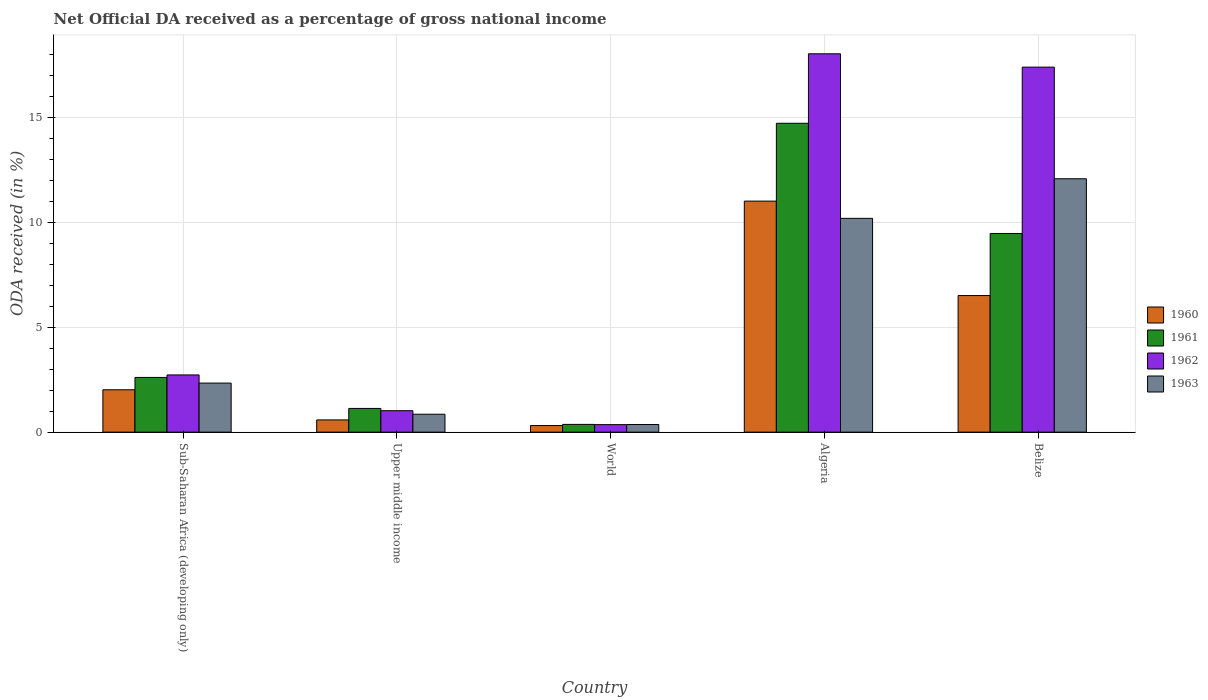Are the number of bars per tick equal to the number of legend labels?
Ensure brevity in your answer.  Yes. Are the number of bars on each tick of the X-axis equal?
Your answer should be compact. Yes. How many bars are there on the 3rd tick from the right?
Your response must be concise. 4. What is the label of the 3rd group of bars from the left?
Offer a terse response. World. In how many cases, is the number of bars for a given country not equal to the number of legend labels?
Provide a succinct answer. 0. What is the net official DA received in 1961 in Belize?
Your answer should be very brief. 9.48. Across all countries, what is the maximum net official DA received in 1963?
Make the answer very short. 12.09. Across all countries, what is the minimum net official DA received in 1961?
Offer a terse response. 0.37. In which country was the net official DA received in 1962 maximum?
Your answer should be very brief. Algeria. In which country was the net official DA received in 1963 minimum?
Offer a very short reply. World. What is the total net official DA received in 1963 in the graph?
Provide a short and direct response. 25.85. What is the difference between the net official DA received in 1963 in Algeria and that in Upper middle income?
Offer a very short reply. 9.34. What is the difference between the net official DA received in 1961 in Upper middle income and the net official DA received in 1960 in Sub-Saharan Africa (developing only)?
Your response must be concise. -0.89. What is the average net official DA received in 1960 per country?
Offer a very short reply. 4.09. What is the difference between the net official DA received of/in 1960 and net official DA received of/in 1963 in Belize?
Your response must be concise. -5.57. What is the ratio of the net official DA received in 1961 in Belize to that in World?
Offer a very short reply. 25.65. Is the net official DA received in 1961 in Algeria less than that in World?
Provide a succinct answer. No. What is the difference between the highest and the second highest net official DA received in 1961?
Provide a succinct answer. 6.87. What is the difference between the highest and the lowest net official DA received in 1963?
Offer a very short reply. 11.72. Is it the case that in every country, the sum of the net official DA received in 1961 and net official DA received in 1962 is greater than the sum of net official DA received in 1960 and net official DA received in 1963?
Make the answer very short. No. What does the 4th bar from the right in Sub-Saharan Africa (developing only) represents?
Give a very brief answer. 1960. What is the difference between two consecutive major ticks on the Y-axis?
Your answer should be compact. 5. Are the values on the major ticks of Y-axis written in scientific E-notation?
Ensure brevity in your answer.  No. Does the graph contain any zero values?
Provide a succinct answer. No. Does the graph contain grids?
Provide a succinct answer. Yes. Where does the legend appear in the graph?
Offer a very short reply. Center right. How many legend labels are there?
Give a very brief answer. 4. How are the legend labels stacked?
Give a very brief answer. Vertical. What is the title of the graph?
Your answer should be compact. Net Official DA received as a percentage of gross national income. What is the label or title of the Y-axis?
Give a very brief answer. ODA received (in %). What is the ODA received (in %) in 1960 in Sub-Saharan Africa (developing only)?
Ensure brevity in your answer.  2.02. What is the ODA received (in %) in 1961 in Sub-Saharan Africa (developing only)?
Offer a very short reply. 2.61. What is the ODA received (in %) of 1962 in Sub-Saharan Africa (developing only)?
Offer a very short reply. 2.73. What is the ODA received (in %) in 1963 in Sub-Saharan Africa (developing only)?
Your answer should be very brief. 2.34. What is the ODA received (in %) of 1960 in Upper middle income?
Make the answer very short. 0.58. What is the ODA received (in %) of 1961 in Upper middle income?
Ensure brevity in your answer.  1.13. What is the ODA received (in %) of 1962 in Upper middle income?
Provide a succinct answer. 1.02. What is the ODA received (in %) of 1963 in Upper middle income?
Your response must be concise. 0.86. What is the ODA received (in %) in 1960 in World?
Your response must be concise. 0.31. What is the ODA received (in %) of 1961 in World?
Make the answer very short. 0.37. What is the ODA received (in %) of 1962 in World?
Provide a short and direct response. 0.36. What is the ODA received (in %) of 1963 in World?
Your answer should be compact. 0.36. What is the ODA received (in %) of 1960 in Algeria?
Keep it short and to the point. 11.02. What is the ODA received (in %) in 1961 in Algeria?
Your answer should be compact. 14.73. What is the ODA received (in %) of 1962 in Algeria?
Offer a very short reply. 18.05. What is the ODA received (in %) in 1963 in Algeria?
Make the answer very short. 10.2. What is the ODA received (in %) in 1960 in Belize?
Your response must be concise. 6.52. What is the ODA received (in %) of 1961 in Belize?
Make the answer very short. 9.48. What is the ODA received (in %) of 1962 in Belize?
Give a very brief answer. 17.41. What is the ODA received (in %) in 1963 in Belize?
Keep it short and to the point. 12.09. Across all countries, what is the maximum ODA received (in %) of 1960?
Ensure brevity in your answer.  11.02. Across all countries, what is the maximum ODA received (in %) in 1961?
Provide a succinct answer. 14.73. Across all countries, what is the maximum ODA received (in %) in 1962?
Offer a terse response. 18.05. Across all countries, what is the maximum ODA received (in %) in 1963?
Provide a succinct answer. 12.09. Across all countries, what is the minimum ODA received (in %) of 1960?
Provide a short and direct response. 0.31. Across all countries, what is the minimum ODA received (in %) of 1961?
Make the answer very short. 0.37. Across all countries, what is the minimum ODA received (in %) of 1962?
Provide a short and direct response. 0.36. Across all countries, what is the minimum ODA received (in %) in 1963?
Ensure brevity in your answer.  0.36. What is the total ODA received (in %) in 1960 in the graph?
Your answer should be compact. 20.46. What is the total ODA received (in %) of 1961 in the graph?
Provide a succinct answer. 28.32. What is the total ODA received (in %) of 1962 in the graph?
Ensure brevity in your answer.  39.57. What is the total ODA received (in %) of 1963 in the graph?
Your answer should be compact. 25.85. What is the difference between the ODA received (in %) of 1960 in Sub-Saharan Africa (developing only) and that in Upper middle income?
Your answer should be compact. 1.44. What is the difference between the ODA received (in %) in 1961 in Sub-Saharan Africa (developing only) and that in Upper middle income?
Your response must be concise. 1.48. What is the difference between the ODA received (in %) of 1962 in Sub-Saharan Africa (developing only) and that in Upper middle income?
Give a very brief answer. 1.71. What is the difference between the ODA received (in %) in 1963 in Sub-Saharan Africa (developing only) and that in Upper middle income?
Offer a very short reply. 1.49. What is the difference between the ODA received (in %) in 1960 in Sub-Saharan Africa (developing only) and that in World?
Offer a terse response. 1.71. What is the difference between the ODA received (in %) in 1961 in Sub-Saharan Africa (developing only) and that in World?
Your answer should be very brief. 2.24. What is the difference between the ODA received (in %) of 1962 in Sub-Saharan Africa (developing only) and that in World?
Your answer should be compact. 2.37. What is the difference between the ODA received (in %) in 1963 in Sub-Saharan Africa (developing only) and that in World?
Ensure brevity in your answer.  1.98. What is the difference between the ODA received (in %) in 1960 in Sub-Saharan Africa (developing only) and that in Algeria?
Your answer should be very brief. -9. What is the difference between the ODA received (in %) in 1961 in Sub-Saharan Africa (developing only) and that in Algeria?
Ensure brevity in your answer.  -12.12. What is the difference between the ODA received (in %) in 1962 in Sub-Saharan Africa (developing only) and that in Algeria?
Provide a short and direct response. -15.32. What is the difference between the ODA received (in %) in 1963 in Sub-Saharan Africa (developing only) and that in Algeria?
Your answer should be very brief. -7.86. What is the difference between the ODA received (in %) in 1960 in Sub-Saharan Africa (developing only) and that in Belize?
Offer a very short reply. -4.49. What is the difference between the ODA received (in %) in 1961 in Sub-Saharan Africa (developing only) and that in Belize?
Provide a short and direct response. -6.87. What is the difference between the ODA received (in %) in 1962 in Sub-Saharan Africa (developing only) and that in Belize?
Offer a terse response. -14.68. What is the difference between the ODA received (in %) of 1963 in Sub-Saharan Africa (developing only) and that in Belize?
Your answer should be very brief. -9.75. What is the difference between the ODA received (in %) in 1960 in Upper middle income and that in World?
Offer a very short reply. 0.27. What is the difference between the ODA received (in %) in 1961 in Upper middle income and that in World?
Keep it short and to the point. 0.76. What is the difference between the ODA received (in %) in 1962 in Upper middle income and that in World?
Ensure brevity in your answer.  0.66. What is the difference between the ODA received (in %) in 1963 in Upper middle income and that in World?
Your answer should be compact. 0.49. What is the difference between the ODA received (in %) of 1960 in Upper middle income and that in Algeria?
Provide a succinct answer. -10.44. What is the difference between the ODA received (in %) of 1961 in Upper middle income and that in Algeria?
Your response must be concise. -13.6. What is the difference between the ODA received (in %) in 1962 in Upper middle income and that in Algeria?
Give a very brief answer. -17.03. What is the difference between the ODA received (in %) of 1963 in Upper middle income and that in Algeria?
Ensure brevity in your answer.  -9.34. What is the difference between the ODA received (in %) in 1960 in Upper middle income and that in Belize?
Provide a succinct answer. -5.93. What is the difference between the ODA received (in %) of 1961 in Upper middle income and that in Belize?
Your response must be concise. -8.35. What is the difference between the ODA received (in %) of 1962 in Upper middle income and that in Belize?
Your answer should be very brief. -16.39. What is the difference between the ODA received (in %) of 1963 in Upper middle income and that in Belize?
Offer a very short reply. -11.23. What is the difference between the ODA received (in %) of 1960 in World and that in Algeria?
Provide a succinct answer. -10.71. What is the difference between the ODA received (in %) of 1961 in World and that in Algeria?
Your answer should be compact. -14.36. What is the difference between the ODA received (in %) in 1962 in World and that in Algeria?
Give a very brief answer. -17.69. What is the difference between the ODA received (in %) in 1963 in World and that in Algeria?
Provide a short and direct response. -9.83. What is the difference between the ODA received (in %) in 1960 in World and that in Belize?
Make the answer very short. -6.2. What is the difference between the ODA received (in %) of 1961 in World and that in Belize?
Ensure brevity in your answer.  -9.11. What is the difference between the ODA received (in %) of 1962 in World and that in Belize?
Provide a short and direct response. -17.05. What is the difference between the ODA received (in %) in 1963 in World and that in Belize?
Your answer should be compact. -11.72. What is the difference between the ODA received (in %) of 1960 in Algeria and that in Belize?
Make the answer very short. 4.51. What is the difference between the ODA received (in %) in 1961 in Algeria and that in Belize?
Offer a very short reply. 5.26. What is the difference between the ODA received (in %) of 1962 in Algeria and that in Belize?
Your answer should be very brief. 0.64. What is the difference between the ODA received (in %) of 1963 in Algeria and that in Belize?
Ensure brevity in your answer.  -1.89. What is the difference between the ODA received (in %) in 1960 in Sub-Saharan Africa (developing only) and the ODA received (in %) in 1961 in Upper middle income?
Provide a succinct answer. 0.89. What is the difference between the ODA received (in %) of 1960 in Sub-Saharan Africa (developing only) and the ODA received (in %) of 1962 in Upper middle income?
Your answer should be very brief. 1. What is the difference between the ODA received (in %) in 1960 in Sub-Saharan Africa (developing only) and the ODA received (in %) in 1963 in Upper middle income?
Offer a terse response. 1.17. What is the difference between the ODA received (in %) in 1961 in Sub-Saharan Africa (developing only) and the ODA received (in %) in 1962 in Upper middle income?
Offer a terse response. 1.59. What is the difference between the ODA received (in %) of 1961 in Sub-Saharan Africa (developing only) and the ODA received (in %) of 1963 in Upper middle income?
Make the answer very short. 1.75. What is the difference between the ODA received (in %) of 1962 in Sub-Saharan Africa (developing only) and the ODA received (in %) of 1963 in Upper middle income?
Offer a terse response. 1.87. What is the difference between the ODA received (in %) of 1960 in Sub-Saharan Africa (developing only) and the ODA received (in %) of 1961 in World?
Keep it short and to the point. 1.65. What is the difference between the ODA received (in %) in 1960 in Sub-Saharan Africa (developing only) and the ODA received (in %) in 1962 in World?
Offer a very short reply. 1.66. What is the difference between the ODA received (in %) of 1960 in Sub-Saharan Africa (developing only) and the ODA received (in %) of 1963 in World?
Give a very brief answer. 1.66. What is the difference between the ODA received (in %) in 1961 in Sub-Saharan Africa (developing only) and the ODA received (in %) in 1962 in World?
Make the answer very short. 2.25. What is the difference between the ODA received (in %) in 1961 in Sub-Saharan Africa (developing only) and the ODA received (in %) in 1963 in World?
Your answer should be very brief. 2.25. What is the difference between the ODA received (in %) in 1962 in Sub-Saharan Africa (developing only) and the ODA received (in %) in 1963 in World?
Make the answer very short. 2.36. What is the difference between the ODA received (in %) of 1960 in Sub-Saharan Africa (developing only) and the ODA received (in %) of 1961 in Algeria?
Provide a succinct answer. -12.71. What is the difference between the ODA received (in %) of 1960 in Sub-Saharan Africa (developing only) and the ODA received (in %) of 1962 in Algeria?
Keep it short and to the point. -16.03. What is the difference between the ODA received (in %) of 1960 in Sub-Saharan Africa (developing only) and the ODA received (in %) of 1963 in Algeria?
Your response must be concise. -8.18. What is the difference between the ODA received (in %) of 1961 in Sub-Saharan Africa (developing only) and the ODA received (in %) of 1962 in Algeria?
Keep it short and to the point. -15.44. What is the difference between the ODA received (in %) in 1961 in Sub-Saharan Africa (developing only) and the ODA received (in %) in 1963 in Algeria?
Offer a terse response. -7.59. What is the difference between the ODA received (in %) of 1962 in Sub-Saharan Africa (developing only) and the ODA received (in %) of 1963 in Algeria?
Your answer should be compact. -7.47. What is the difference between the ODA received (in %) of 1960 in Sub-Saharan Africa (developing only) and the ODA received (in %) of 1961 in Belize?
Make the answer very short. -7.46. What is the difference between the ODA received (in %) of 1960 in Sub-Saharan Africa (developing only) and the ODA received (in %) of 1962 in Belize?
Keep it short and to the point. -15.39. What is the difference between the ODA received (in %) of 1960 in Sub-Saharan Africa (developing only) and the ODA received (in %) of 1963 in Belize?
Provide a succinct answer. -10.07. What is the difference between the ODA received (in %) of 1961 in Sub-Saharan Africa (developing only) and the ODA received (in %) of 1962 in Belize?
Make the answer very short. -14.8. What is the difference between the ODA received (in %) in 1961 in Sub-Saharan Africa (developing only) and the ODA received (in %) in 1963 in Belize?
Ensure brevity in your answer.  -9.48. What is the difference between the ODA received (in %) of 1962 in Sub-Saharan Africa (developing only) and the ODA received (in %) of 1963 in Belize?
Your answer should be compact. -9.36. What is the difference between the ODA received (in %) of 1960 in Upper middle income and the ODA received (in %) of 1961 in World?
Keep it short and to the point. 0.21. What is the difference between the ODA received (in %) in 1960 in Upper middle income and the ODA received (in %) in 1962 in World?
Give a very brief answer. 0.23. What is the difference between the ODA received (in %) in 1960 in Upper middle income and the ODA received (in %) in 1963 in World?
Your response must be concise. 0.22. What is the difference between the ODA received (in %) of 1961 in Upper middle income and the ODA received (in %) of 1962 in World?
Offer a very short reply. 0.77. What is the difference between the ODA received (in %) of 1961 in Upper middle income and the ODA received (in %) of 1963 in World?
Ensure brevity in your answer.  0.77. What is the difference between the ODA received (in %) of 1962 in Upper middle income and the ODA received (in %) of 1963 in World?
Your response must be concise. 0.66. What is the difference between the ODA received (in %) in 1960 in Upper middle income and the ODA received (in %) in 1961 in Algeria?
Offer a very short reply. -14.15. What is the difference between the ODA received (in %) of 1960 in Upper middle income and the ODA received (in %) of 1962 in Algeria?
Provide a short and direct response. -17.46. What is the difference between the ODA received (in %) of 1960 in Upper middle income and the ODA received (in %) of 1963 in Algeria?
Your response must be concise. -9.61. What is the difference between the ODA received (in %) of 1961 in Upper middle income and the ODA received (in %) of 1962 in Algeria?
Make the answer very short. -16.92. What is the difference between the ODA received (in %) of 1961 in Upper middle income and the ODA received (in %) of 1963 in Algeria?
Provide a short and direct response. -9.07. What is the difference between the ODA received (in %) of 1962 in Upper middle income and the ODA received (in %) of 1963 in Algeria?
Give a very brief answer. -9.18. What is the difference between the ODA received (in %) in 1960 in Upper middle income and the ODA received (in %) in 1961 in Belize?
Your answer should be compact. -8.89. What is the difference between the ODA received (in %) in 1960 in Upper middle income and the ODA received (in %) in 1962 in Belize?
Ensure brevity in your answer.  -16.83. What is the difference between the ODA received (in %) in 1960 in Upper middle income and the ODA received (in %) in 1963 in Belize?
Offer a very short reply. -11.5. What is the difference between the ODA received (in %) in 1961 in Upper middle income and the ODA received (in %) in 1962 in Belize?
Your response must be concise. -16.28. What is the difference between the ODA received (in %) of 1961 in Upper middle income and the ODA received (in %) of 1963 in Belize?
Keep it short and to the point. -10.96. What is the difference between the ODA received (in %) in 1962 in Upper middle income and the ODA received (in %) in 1963 in Belize?
Give a very brief answer. -11.07. What is the difference between the ODA received (in %) in 1960 in World and the ODA received (in %) in 1961 in Algeria?
Provide a short and direct response. -14.42. What is the difference between the ODA received (in %) of 1960 in World and the ODA received (in %) of 1962 in Algeria?
Offer a very short reply. -17.73. What is the difference between the ODA received (in %) of 1960 in World and the ODA received (in %) of 1963 in Algeria?
Your response must be concise. -9.88. What is the difference between the ODA received (in %) in 1961 in World and the ODA received (in %) in 1962 in Algeria?
Give a very brief answer. -17.68. What is the difference between the ODA received (in %) of 1961 in World and the ODA received (in %) of 1963 in Algeria?
Your answer should be compact. -9.83. What is the difference between the ODA received (in %) in 1962 in World and the ODA received (in %) in 1963 in Algeria?
Your response must be concise. -9.84. What is the difference between the ODA received (in %) in 1960 in World and the ODA received (in %) in 1961 in Belize?
Give a very brief answer. -9.16. What is the difference between the ODA received (in %) of 1960 in World and the ODA received (in %) of 1962 in Belize?
Ensure brevity in your answer.  -17.1. What is the difference between the ODA received (in %) in 1960 in World and the ODA received (in %) in 1963 in Belize?
Keep it short and to the point. -11.77. What is the difference between the ODA received (in %) of 1961 in World and the ODA received (in %) of 1962 in Belize?
Offer a terse response. -17.04. What is the difference between the ODA received (in %) in 1961 in World and the ODA received (in %) in 1963 in Belize?
Provide a succinct answer. -11.72. What is the difference between the ODA received (in %) of 1962 in World and the ODA received (in %) of 1963 in Belize?
Your answer should be very brief. -11.73. What is the difference between the ODA received (in %) of 1960 in Algeria and the ODA received (in %) of 1961 in Belize?
Provide a short and direct response. 1.54. What is the difference between the ODA received (in %) of 1960 in Algeria and the ODA received (in %) of 1962 in Belize?
Ensure brevity in your answer.  -6.39. What is the difference between the ODA received (in %) in 1960 in Algeria and the ODA received (in %) in 1963 in Belize?
Offer a very short reply. -1.07. What is the difference between the ODA received (in %) in 1961 in Algeria and the ODA received (in %) in 1962 in Belize?
Give a very brief answer. -2.68. What is the difference between the ODA received (in %) in 1961 in Algeria and the ODA received (in %) in 1963 in Belize?
Your answer should be compact. 2.65. What is the difference between the ODA received (in %) of 1962 in Algeria and the ODA received (in %) of 1963 in Belize?
Offer a terse response. 5.96. What is the average ODA received (in %) of 1960 per country?
Your answer should be compact. 4.09. What is the average ODA received (in %) in 1961 per country?
Your response must be concise. 5.66. What is the average ODA received (in %) of 1962 per country?
Offer a very short reply. 7.91. What is the average ODA received (in %) of 1963 per country?
Make the answer very short. 5.17. What is the difference between the ODA received (in %) in 1960 and ODA received (in %) in 1961 in Sub-Saharan Africa (developing only)?
Ensure brevity in your answer.  -0.59. What is the difference between the ODA received (in %) of 1960 and ODA received (in %) of 1962 in Sub-Saharan Africa (developing only)?
Give a very brief answer. -0.71. What is the difference between the ODA received (in %) in 1960 and ODA received (in %) in 1963 in Sub-Saharan Africa (developing only)?
Give a very brief answer. -0.32. What is the difference between the ODA received (in %) in 1961 and ODA received (in %) in 1962 in Sub-Saharan Africa (developing only)?
Provide a succinct answer. -0.12. What is the difference between the ODA received (in %) of 1961 and ODA received (in %) of 1963 in Sub-Saharan Africa (developing only)?
Your response must be concise. 0.27. What is the difference between the ODA received (in %) of 1962 and ODA received (in %) of 1963 in Sub-Saharan Africa (developing only)?
Provide a short and direct response. 0.39. What is the difference between the ODA received (in %) in 1960 and ODA received (in %) in 1961 in Upper middle income?
Keep it short and to the point. -0.55. What is the difference between the ODA received (in %) in 1960 and ODA received (in %) in 1962 in Upper middle income?
Give a very brief answer. -0.44. What is the difference between the ODA received (in %) of 1960 and ODA received (in %) of 1963 in Upper middle income?
Give a very brief answer. -0.27. What is the difference between the ODA received (in %) in 1961 and ODA received (in %) in 1962 in Upper middle income?
Offer a terse response. 0.11. What is the difference between the ODA received (in %) in 1961 and ODA received (in %) in 1963 in Upper middle income?
Your answer should be compact. 0.28. What is the difference between the ODA received (in %) in 1962 and ODA received (in %) in 1963 in Upper middle income?
Your answer should be very brief. 0.17. What is the difference between the ODA received (in %) of 1960 and ODA received (in %) of 1961 in World?
Make the answer very short. -0.06. What is the difference between the ODA received (in %) in 1960 and ODA received (in %) in 1962 in World?
Offer a terse response. -0.04. What is the difference between the ODA received (in %) in 1960 and ODA received (in %) in 1963 in World?
Offer a terse response. -0.05. What is the difference between the ODA received (in %) of 1961 and ODA received (in %) of 1962 in World?
Keep it short and to the point. 0.01. What is the difference between the ODA received (in %) of 1961 and ODA received (in %) of 1963 in World?
Your response must be concise. 0. What is the difference between the ODA received (in %) in 1962 and ODA received (in %) in 1963 in World?
Provide a succinct answer. -0.01. What is the difference between the ODA received (in %) in 1960 and ODA received (in %) in 1961 in Algeria?
Your answer should be very brief. -3.71. What is the difference between the ODA received (in %) in 1960 and ODA received (in %) in 1962 in Algeria?
Your response must be concise. -7.03. What is the difference between the ODA received (in %) of 1960 and ODA received (in %) of 1963 in Algeria?
Give a very brief answer. 0.82. What is the difference between the ODA received (in %) of 1961 and ODA received (in %) of 1962 in Algeria?
Keep it short and to the point. -3.31. What is the difference between the ODA received (in %) in 1961 and ODA received (in %) in 1963 in Algeria?
Your answer should be compact. 4.54. What is the difference between the ODA received (in %) of 1962 and ODA received (in %) of 1963 in Algeria?
Ensure brevity in your answer.  7.85. What is the difference between the ODA received (in %) in 1960 and ODA received (in %) in 1961 in Belize?
Keep it short and to the point. -2.96. What is the difference between the ODA received (in %) of 1960 and ODA received (in %) of 1962 in Belize?
Give a very brief answer. -10.9. What is the difference between the ODA received (in %) in 1960 and ODA received (in %) in 1963 in Belize?
Ensure brevity in your answer.  -5.57. What is the difference between the ODA received (in %) of 1961 and ODA received (in %) of 1962 in Belize?
Make the answer very short. -7.93. What is the difference between the ODA received (in %) of 1961 and ODA received (in %) of 1963 in Belize?
Ensure brevity in your answer.  -2.61. What is the difference between the ODA received (in %) of 1962 and ODA received (in %) of 1963 in Belize?
Provide a succinct answer. 5.32. What is the ratio of the ODA received (in %) of 1960 in Sub-Saharan Africa (developing only) to that in Upper middle income?
Ensure brevity in your answer.  3.46. What is the ratio of the ODA received (in %) of 1961 in Sub-Saharan Africa (developing only) to that in Upper middle income?
Provide a succinct answer. 2.31. What is the ratio of the ODA received (in %) of 1962 in Sub-Saharan Africa (developing only) to that in Upper middle income?
Offer a very short reply. 2.67. What is the ratio of the ODA received (in %) in 1963 in Sub-Saharan Africa (developing only) to that in Upper middle income?
Your answer should be very brief. 2.74. What is the ratio of the ODA received (in %) in 1960 in Sub-Saharan Africa (developing only) to that in World?
Keep it short and to the point. 6.43. What is the ratio of the ODA received (in %) of 1961 in Sub-Saharan Africa (developing only) to that in World?
Offer a terse response. 7.06. What is the ratio of the ODA received (in %) of 1962 in Sub-Saharan Africa (developing only) to that in World?
Offer a terse response. 7.62. What is the ratio of the ODA received (in %) in 1963 in Sub-Saharan Africa (developing only) to that in World?
Your answer should be very brief. 6.42. What is the ratio of the ODA received (in %) of 1960 in Sub-Saharan Africa (developing only) to that in Algeria?
Provide a succinct answer. 0.18. What is the ratio of the ODA received (in %) of 1961 in Sub-Saharan Africa (developing only) to that in Algeria?
Offer a very short reply. 0.18. What is the ratio of the ODA received (in %) in 1962 in Sub-Saharan Africa (developing only) to that in Algeria?
Ensure brevity in your answer.  0.15. What is the ratio of the ODA received (in %) in 1963 in Sub-Saharan Africa (developing only) to that in Algeria?
Give a very brief answer. 0.23. What is the ratio of the ODA received (in %) of 1960 in Sub-Saharan Africa (developing only) to that in Belize?
Offer a terse response. 0.31. What is the ratio of the ODA received (in %) in 1961 in Sub-Saharan Africa (developing only) to that in Belize?
Keep it short and to the point. 0.28. What is the ratio of the ODA received (in %) of 1962 in Sub-Saharan Africa (developing only) to that in Belize?
Ensure brevity in your answer.  0.16. What is the ratio of the ODA received (in %) in 1963 in Sub-Saharan Africa (developing only) to that in Belize?
Make the answer very short. 0.19. What is the ratio of the ODA received (in %) of 1960 in Upper middle income to that in World?
Make the answer very short. 1.86. What is the ratio of the ODA received (in %) in 1961 in Upper middle income to that in World?
Your answer should be very brief. 3.06. What is the ratio of the ODA received (in %) of 1962 in Upper middle income to that in World?
Offer a terse response. 2.85. What is the ratio of the ODA received (in %) of 1963 in Upper middle income to that in World?
Your answer should be very brief. 2.34. What is the ratio of the ODA received (in %) in 1960 in Upper middle income to that in Algeria?
Keep it short and to the point. 0.05. What is the ratio of the ODA received (in %) in 1961 in Upper middle income to that in Algeria?
Offer a terse response. 0.08. What is the ratio of the ODA received (in %) in 1962 in Upper middle income to that in Algeria?
Your answer should be very brief. 0.06. What is the ratio of the ODA received (in %) in 1963 in Upper middle income to that in Algeria?
Keep it short and to the point. 0.08. What is the ratio of the ODA received (in %) in 1960 in Upper middle income to that in Belize?
Give a very brief answer. 0.09. What is the ratio of the ODA received (in %) of 1961 in Upper middle income to that in Belize?
Give a very brief answer. 0.12. What is the ratio of the ODA received (in %) of 1962 in Upper middle income to that in Belize?
Ensure brevity in your answer.  0.06. What is the ratio of the ODA received (in %) of 1963 in Upper middle income to that in Belize?
Your response must be concise. 0.07. What is the ratio of the ODA received (in %) of 1960 in World to that in Algeria?
Make the answer very short. 0.03. What is the ratio of the ODA received (in %) of 1961 in World to that in Algeria?
Make the answer very short. 0.03. What is the ratio of the ODA received (in %) of 1962 in World to that in Algeria?
Offer a terse response. 0.02. What is the ratio of the ODA received (in %) of 1963 in World to that in Algeria?
Your response must be concise. 0.04. What is the ratio of the ODA received (in %) in 1960 in World to that in Belize?
Provide a succinct answer. 0.05. What is the ratio of the ODA received (in %) of 1961 in World to that in Belize?
Offer a terse response. 0.04. What is the ratio of the ODA received (in %) in 1962 in World to that in Belize?
Make the answer very short. 0.02. What is the ratio of the ODA received (in %) of 1963 in World to that in Belize?
Offer a very short reply. 0.03. What is the ratio of the ODA received (in %) of 1960 in Algeria to that in Belize?
Offer a very short reply. 1.69. What is the ratio of the ODA received (in %) in 1961 in Algeria to that in Belize?
Your response must be concise. 1.55. What is the ratio of the ODA received (in %) of 1962 in Algeria to that in Belize?
Your response must be concise. 1.04. What is the ratio of the ODA received (in %) of 1963 in Algeria to that in Belize?
Offer a terse response. 0.84. What is the difference between the highest and the second highest ODA received (in %) in 1960?
Ensure brevity in your answer.  4.51. What is the difference between the highest and the second highest ODA received (in %) in 1961?
Ensure brevity in your answer.  5.26. What is the difference between the highest and the second highest ODA received (in %) of 1962?
Make the answer very short. 0.64. What is the difference between the highest and the second highest ODA received (in %) in 1963?
Ensure brevity in your answer.  1.89. What is the difference between the highest and the lowest ODA received (in %) of 1960?
Give a very brief answer. 10.71. What is the difference between the highest and the lowest ODA received (in %) of 1961?
Ensure brevity in your answer.  14.36. What is the difference between the highest and the lowest ODA received (in %) of 1962?
Your response must be concise. 17.69. What is the difference between the highest and the lowest ODA received (in %) in 1963?
Provide a short and direct response. 11.72. 